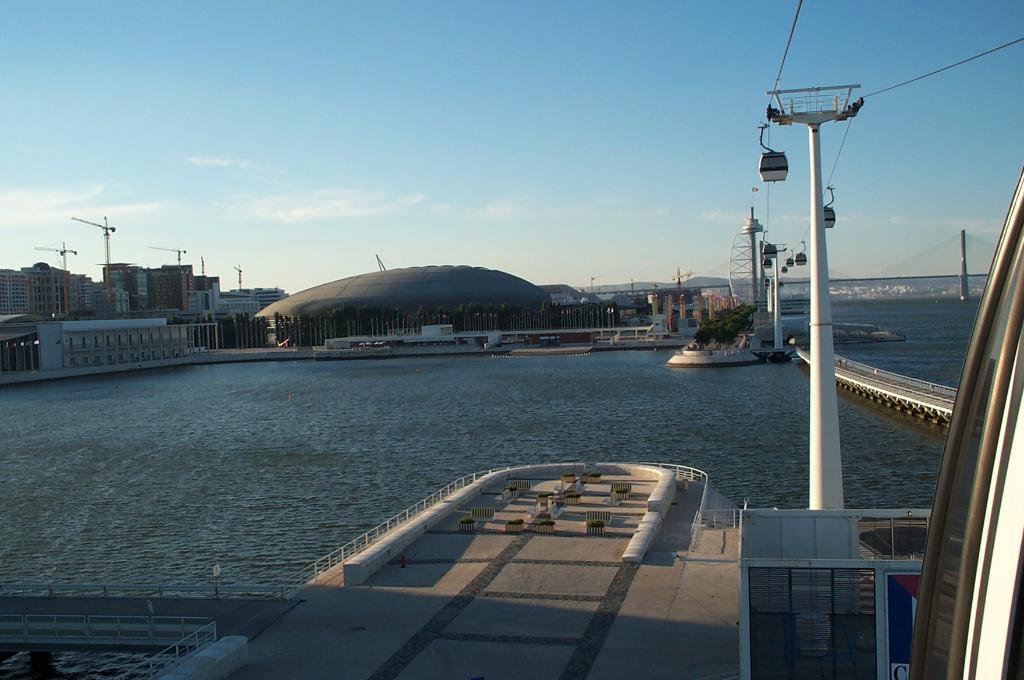Can you describe this image briefly? In the image in the center we can see one boat. In the background we can see sky,clouds,poles,buildings,wall,roof,water,fence,boats etc. 